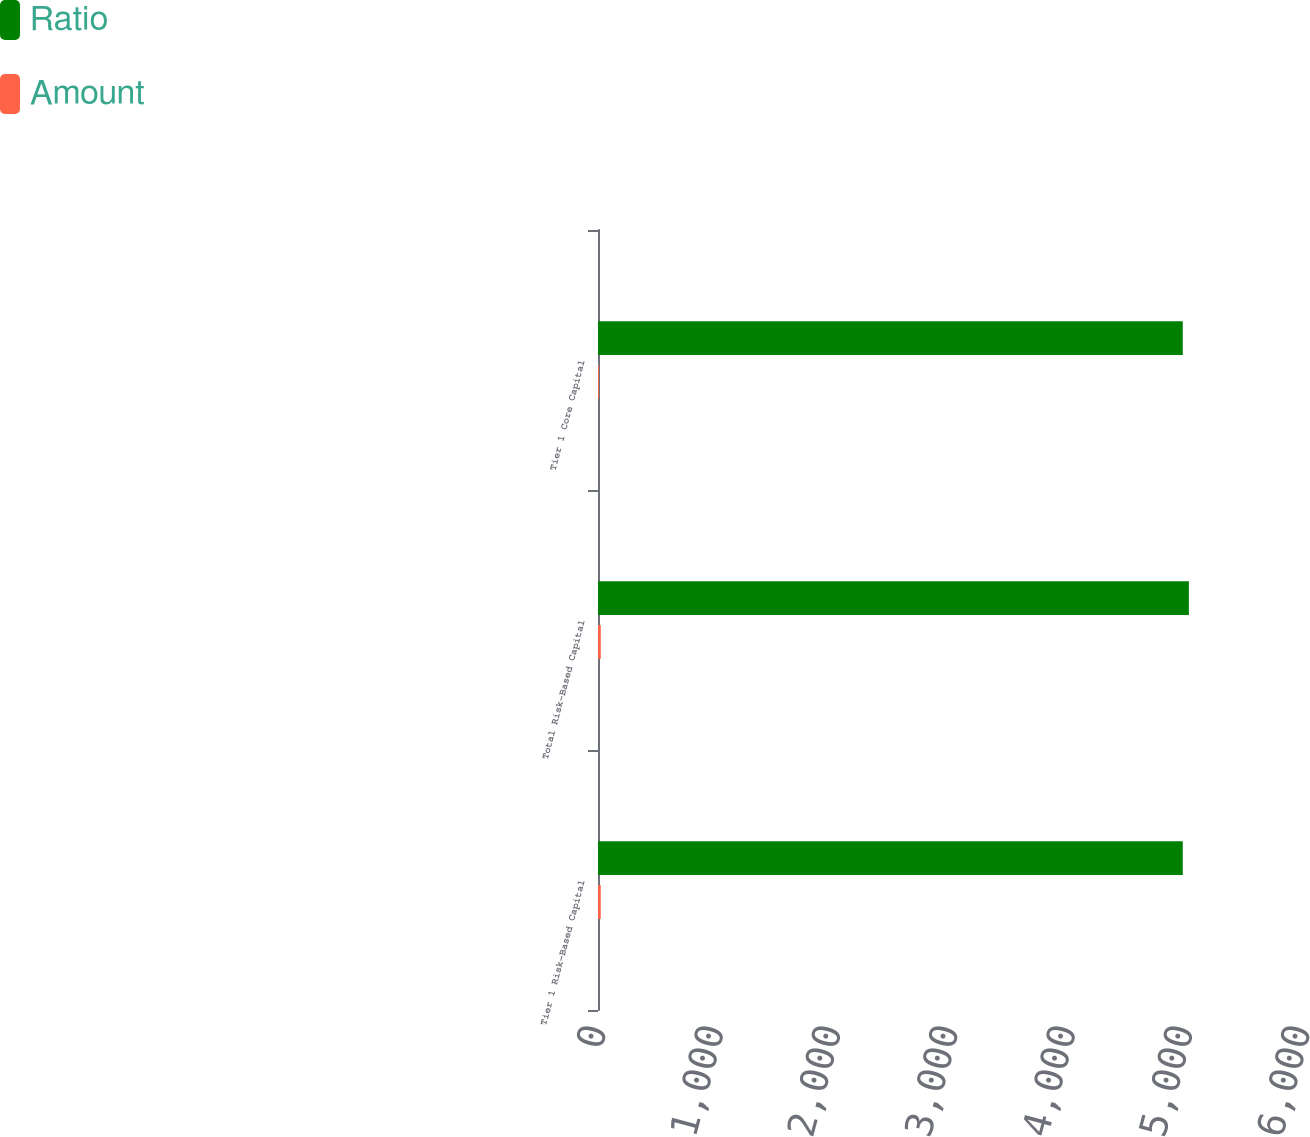Convert chart. <chart><loc_0><loc_0><loc_500><loc_500><stacked_bar_chart><ecel><fcel>Tier 1 Risk-Based Capital<fcel>Total Risk-Based Capital<fcel>Tier 1 Core Capital<nl><fcel>Ratio<fcel>4984<fcel>5036<fcel>4984<nl><fcel>Amount<fcel>23.4<fcel>23.7<fcel>7.5<nl></chart> 